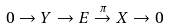Convert formula to latex. <formula><loc_0><loc_0><loc_500><loc_500>0 \rightarrow Y \rightarrow E \overset { \pi } { \rightarrow } X \rightarrow 0</formula> 